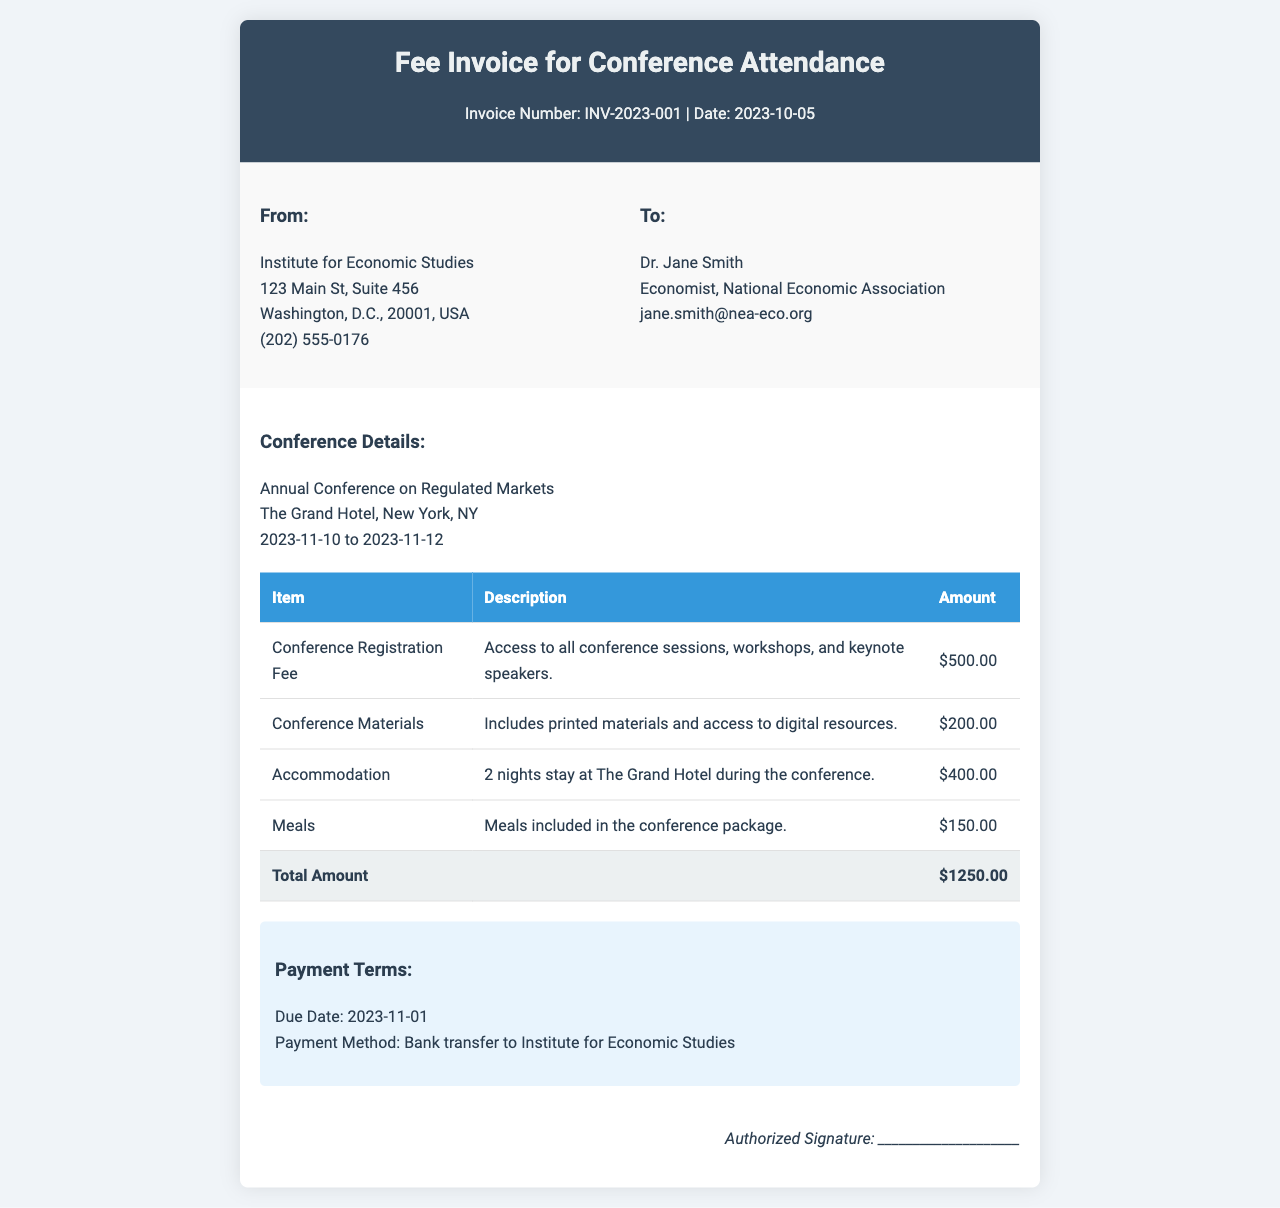What is the invoice number? The invoice number is clearly stated near the top of the document.
Answer: INV-2023-001 Who is the sender of the invoice? The sender's information is provided in the "From" section of the invoice.
Answer: Institute for Economic Studies What is the total amount due? The total amount is summarized in the last row of the itemized list.
Answer: $1250.00 What is the due date for payment? The due date is mentioned in the payment terms section of the invoice.
Answer: 2023-11-01 How many nights of accommodation are included? The description for accommodation specifies the number of nights.
Answer: 2 nights What type of conference is this invoice for? The type of conference is indicated in the details section near the top.
Answer: Annual Conference on Regulated Markets What is included in the conference materials? The description of conference materials specifies the contents provided.
Answer: Printed materials and access to digital resources What payment method is specified? The payment method is stated in the payment terms section.
Answer: Bank transfer What is the conference start date? The start date of the conference is indicated in the details section.
Answer: 2023-11-10 What is the amount for the conference registration fee? The registration fee amount is listed in the itemized charges table.
Answer: $500.00 